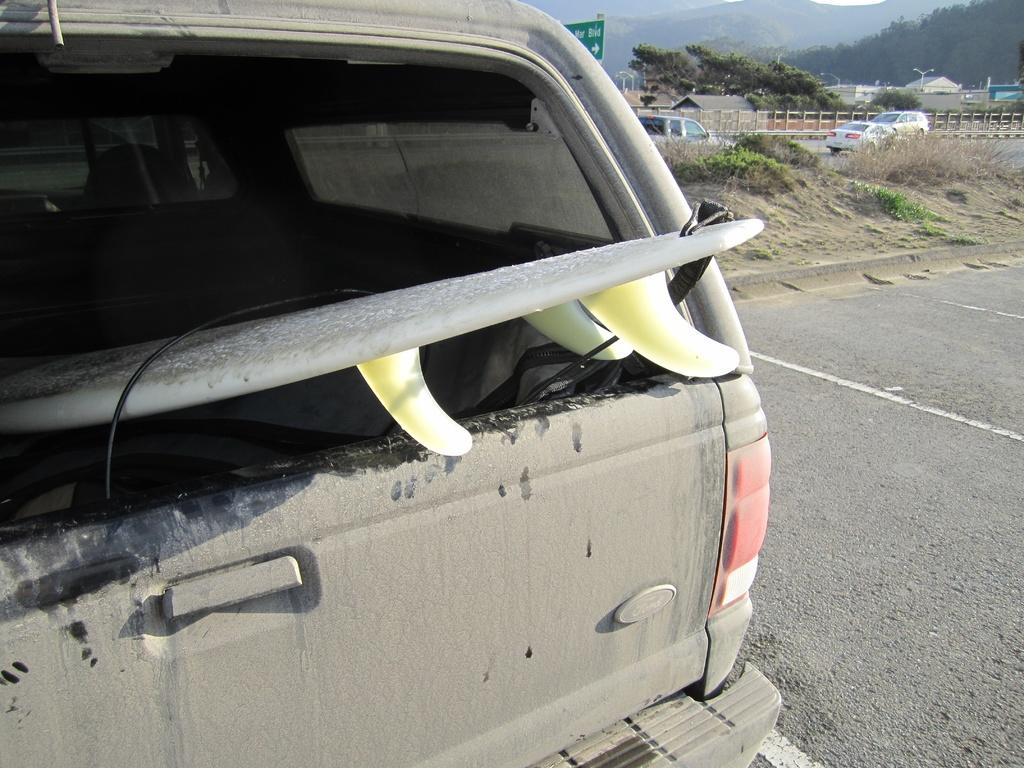What is the main subject in the image? There is a vehicle in the image. Can you describe the surroundings of the vehicle? There are other vehicles visible in the background, and trees and plants in green color are present in the image. What is the color of the board in the image? The green color board is present in the image. How is the sky depicted in the image? The sky is in white color in the image. What type of stew is being cooked on the volcano in the image? There is no stew or volcano present in the image; it features a vehicle, other vehicles, trees and plants, a green color board, and a white sky. How many sticks are visible in the image? There are no sticks visible in the image. 